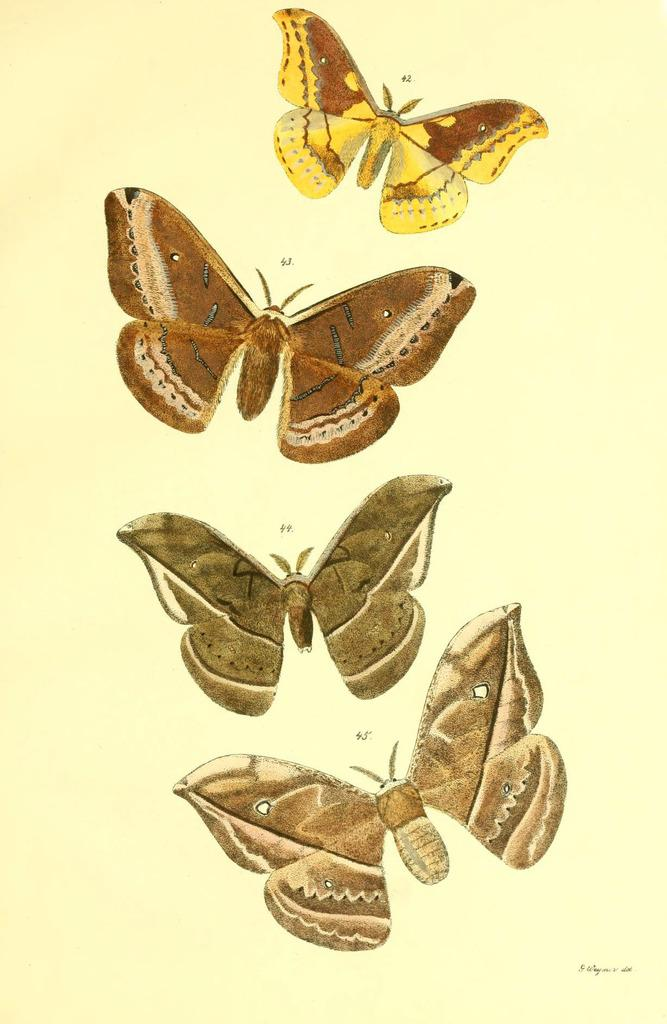What is the main subject of the image? There is a painting in the image. What is the medium of the painting? The painting is on paper. What is depicted in the painting? The painting depicts butterflies. What colors are used for the butterflies in the painting? The butterflies are in brown, yellow, and cream colors. Can you tell me how many animals are in the zoo in the image? There is no zoo present in the image; it features a painting of butterflies. What is the interest of the person viewing the painting in the image? The image does not provide information about the interest of the person viewing the painting. 